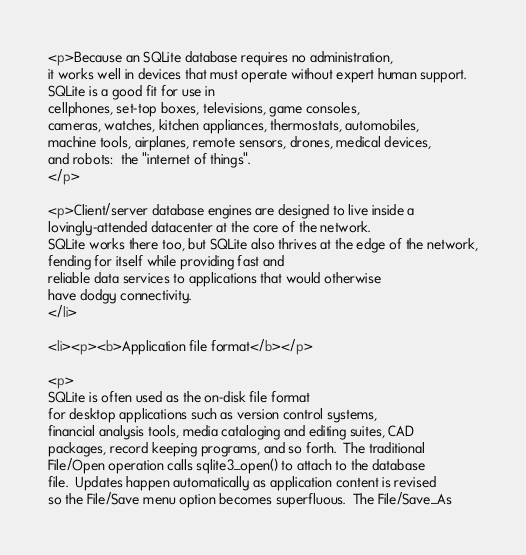Convert code to text. <code><loc_0><loc_0><loc_500><loc_500><_HTML_>
<p>Because an SQLite database requires no administration,
it works well in devices that must operate without expert human support.
SQLite is a good fit for use in 
cellphones, set-top boxes, televisions, game consoles,
cameras, watches, kitchen appliances, thermostats, automobiles, 
machine tools, airplanes, remote sensors, drones, medical devices,
and robots:  the "internet of things".
</p>

<p>Client/server database engines are designed to live inside a
lovingly-attended datacenter at the core of the network.
SQLite works there too, but SQLite also thrives at the edge of the network,
fending for itself while providing fast and
reliable data services to applications that would otherwise
have dodgy connectivity.
</li>

<li><p><b>Application file format</b></p>

<p>
SQLite is often used as the on-disk file format
for desktop applications such as version control systems,
financial analysis tools, media cataloging and editing suites, CAD
packages, record keeping programs, and so forth.  The traditional
File/Open operation calls sqlite3_open() to attach to the database
file.  Updates happen automatically as application content is revised
so the File/Save menu option becomes superfluous.  The File/Save_As</code> 